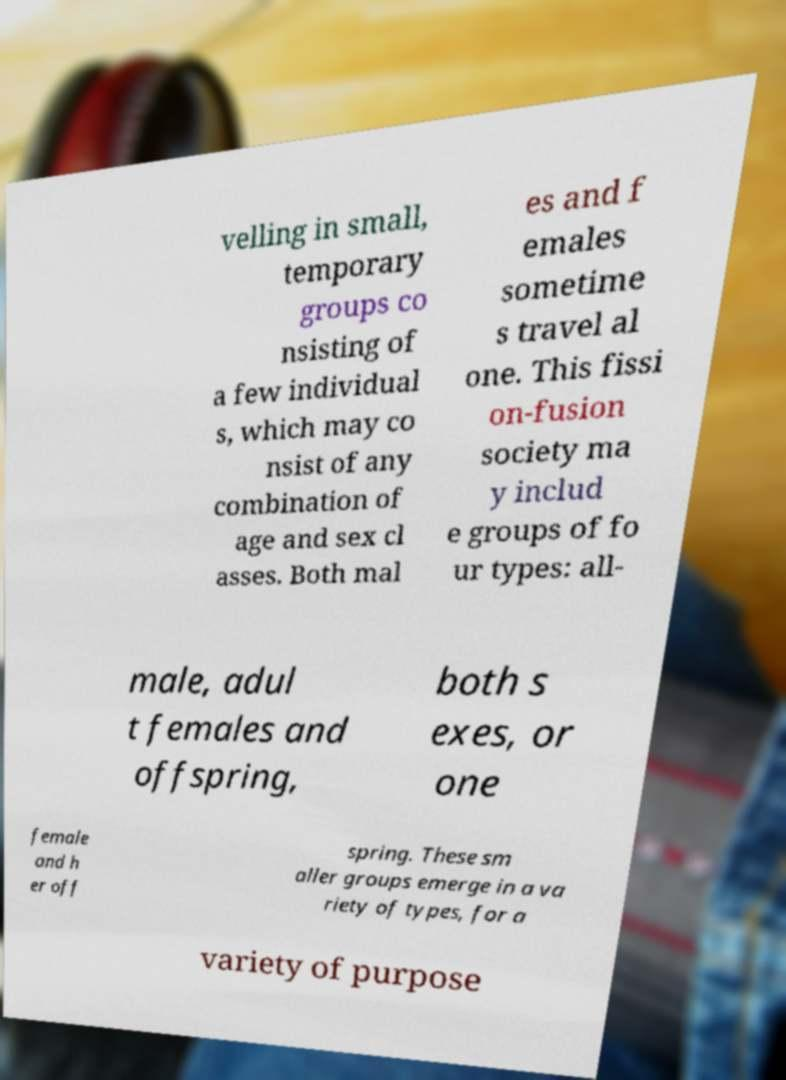For documentation purposes, I need the text within this image transcribed. Could you provide that? velling in small, temporary groups co nsisting of a few individual s, which may co nsist of any combination of age and sex cl asses. Both mal es and f emales sometime s travel al one. This fissi on-fusion society ma y includ e groups of fo ur types: all- male, adul t females and offspring, both s exes, or one female and h er off spring. These sm aller groups emerge in a va riety of types, for a variety of purpose 